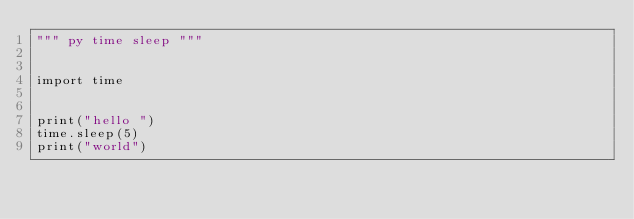Convert code to text. <code><loc_0><loc_0><loc_500><loc_500><_Python_>""" py time sleep """


import time


print("hello ")
time.sleep(5)
print("world")</code> 